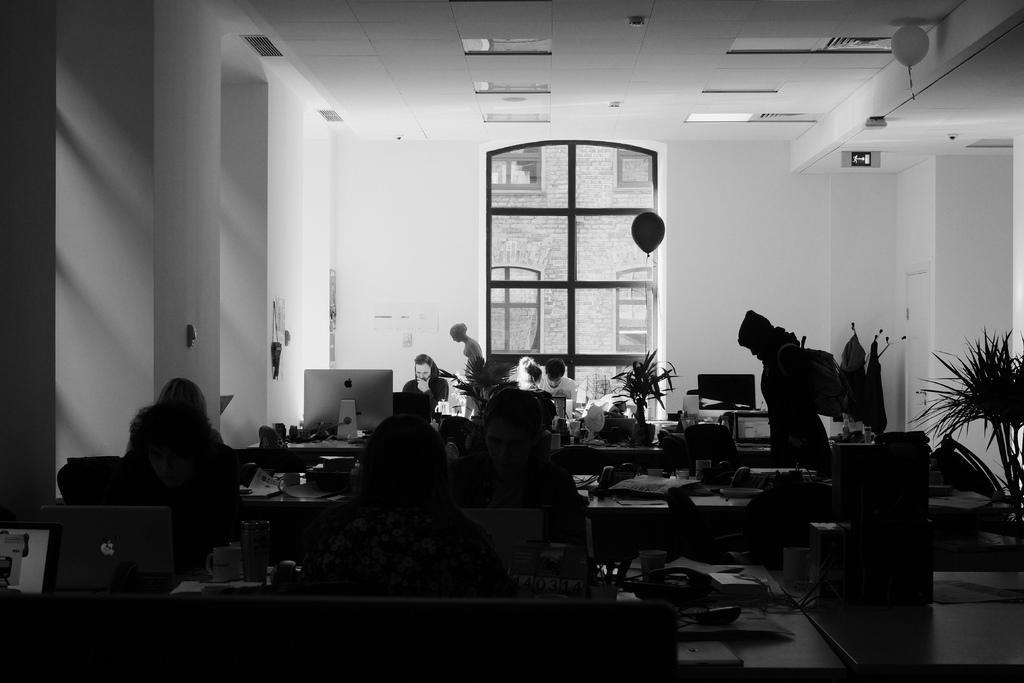Can you describe this image briefly? This picture shows an inner view of a room we see few people seated and working on the laptops and we see a plant and a balloon. 